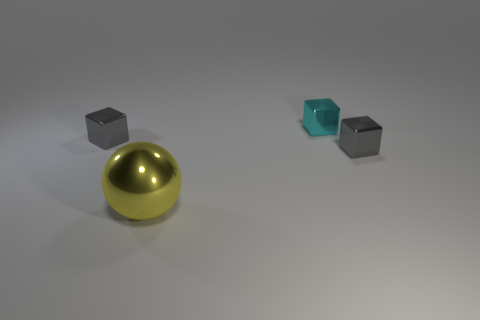There is a object left of the metallic ball; is it the same size as the gray object that is on the right side of the cyan metal cube?
Offer a very short reply. Yes. There is a tiny metal object left of the yellow metal thing to the left of the tiny cyan metallic cube; is there a yellow thing behind it?
Your answer should be compact. No. Is the number of large spheres in front of the yellow object less than the number of blocks that are behind the tiny cyan metal block?
Offer a terse response. No. What shape is the cyan thing that is made of the same material as the ball?
Your response must be concise. Cube. There is a gray cube that is behind the small gray shiny cube in front of the gray metallic object to the left of the cyan metal block; how big is it?
Keep it short and to the point. Small. Are there more small cyan metallic blocks than cyan rubber cylinders?
Keep it short and to the point. Yes. There is a tiny shiny block that is to the left of the large metal sphere; is its color the same as the tiny cube that is to the right of the cyan metal block?
Ensure brevity in your answer.  Yes. Do the thing to the left of the sphere and the gray cube that is to the right of the yellow metallic object have the same material?
Make the answer very short. Yes. What number of cyan cubes have the same size as the yellow metallic thing?
Your answer should be compact. 0. Is the number of small cyan things less than the number of blocks?
Make the answer very short. Yes. 